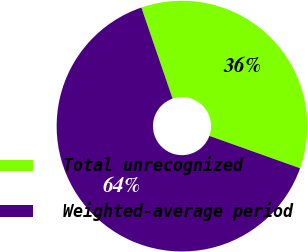<chart> <loc_0><loc_0><loc_500><loc_500><pie_chart><fcel>Total unrecognized<fcel>Weighted-average period<nl><fcel>35.71%<fcel>64.29%<nl></chart> 